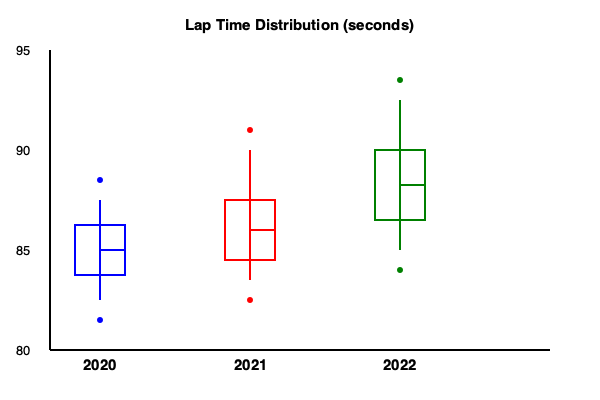Based on the box plots shown in the graph, which statement accurately describes the trend in lap time variability across the three Formula One seasons from 2020 to 2022? To analyze the trend in lap time variability, we need to examine the interquartile range (IQR) and the overall range of each box plot:

1. 2020 season (blue):
   - IQR (box height): 50 units
   - Overall range (whisker length): 120 units

2. 2021 season (red):
   - IQR: 60 units
   - Overall range: 170 units

3. 2022 season (green):
   - IQR: 70 units
   - Overall range: 190 units

We can observe that:
1. The IQR is increasing from 2020 to 2022 (50 < 60 < 70).
2. The overall range is also increasing from 2020 to 2022 (120 < 170 < 190).

Both the IQR and overall range are measures of variability. An increase in these measures indicates an increase in lap time variability.

Additionally, we can see that the median lap times (represented by the line inside each box) are decreasing from 2020 to 2022, indicating faster overall lap times.

Therefore, the trend shows increasing variability in lap times across the three seasons, despite the general improvement in lap times.
Answer: Increasing lap time variability from 2020 to 2022 